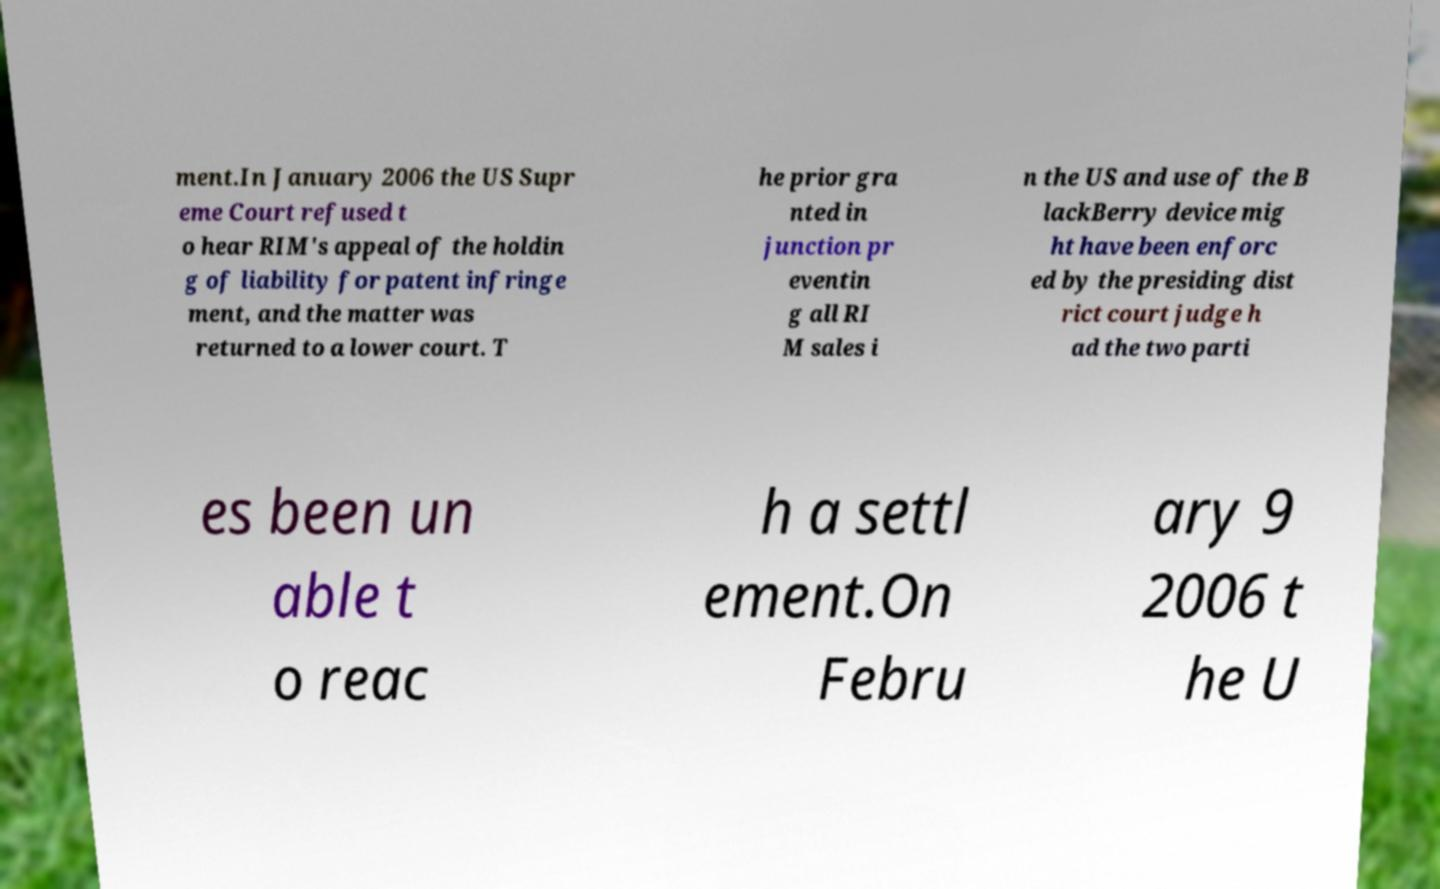Could you assist in decoding the text presented in this image and type it out clearly? ment.In January 2006 the US Supr eme Court refused t o hear RIM's appeal of the holdin g of liability for patent infringe ment, and the matter was returned to a lower court. T he prior gra nted in junction pr eventin g all RI M sales i n the US and use of the B lackBerry device mig ht have been enforc ed by the presiding dist rict court judge h ad the two parti es been un able t o reac h a settl ement.On Febru ary 9 2006 t he U 